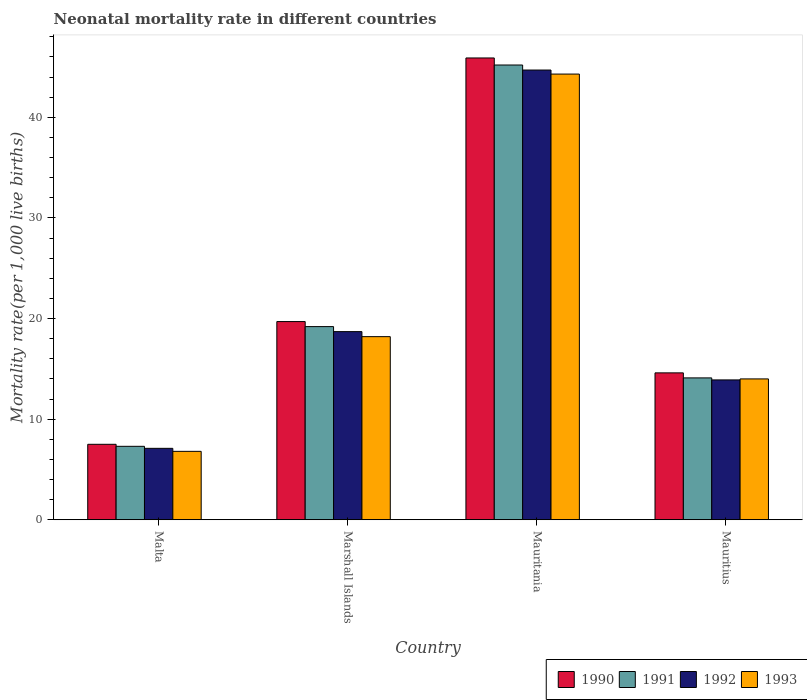Are the number of bars on each tick of the X-axis equal?
Ensure brevity in your answer.  Yes. How many bars are there on the 2nd tick from the left?
Give a very brief answer. 4. How many bars are there on the 4th tick from the right?
Provide a succinct answer. 4. What is the label of the 3rd group of bars from the left?
Keep it short and to the point. Mauritania. In how many cases, is the number of bars for a given country not equal to the number of legend labels?
Give a very brief answer. 0. What is the neonatal mortality rate in 1993 in Mauritius?
Ensure brevity in your answer.  14. Across all countries, what is the maximum neonatal mortality rate in 1993?
Your answer should be very brief. 44.3. Across all countries, what is the minimum neonatal mortality rate in 1990?
Offer a very short reply. 7.5. In which country was the neonatal mortality rate in 1990 maximum?
Ensure brevity in your answer.  Mauritania. In which country was the neonatal mortality rate in 1990 minimum?
Make the answer very short. Malta. What is the total neonatal mortality rate in 1990 in the graph?
Your answer should be very brief. 87.7. What is the difference between the neonatal mortality rate in 1991 in Marshall Islands and that in Mauritania?
Your answer should be very brief. -26. What is the difference between the neonatal mortality rate in 1990 in Marshall Islands and the neonatal mortality rate in 1991 in Mauritius?
Your answer should be very brief. 5.6. What is the average neonatal mortality rate in 1990 per country?
Your response must be concise. 21.92. What is the ratio of the neonatal mortality rate in 1991 in Marshall Islands to that in Mauritius?
Offer a very short reply. 1.36. Is the neonatal mortality rate in 1992 in Marshall Islands less than that in Mauritania?
Make the answer very short. Yes. What is the difference between the highest and the second highest neonatal mortality rate in 1991?
Provide a succinct answer. -26. What is the difference between the highest and the lowest neonatal mortality rate in 1990?
Your response must be concise. 38.4. Is it the case that in every country, the sum of the neonatal mortality rate in 1991 and neonatal mortality rate in 1992 is greater than the sum of neonatal mortality rate in 1990 and neonatal mortality rate in 1993?
Your answer should be very brief. No. What does the 4th bar from the left in Malta represents?
Keep it short and to the point. 1993. Does the graph contain any zero values?
Your response must be concise. No. Where does the legend appear in the graph?
Provide a short and direct response. Bottom right. How are the legend labels stacked?
Make the answer very short. Horizontal. What is the title of the graph?
Offer a terse response. Neonatal mortality rate in different countries. Does "1986" appear as one of the legend labels in the graph?
Provide a succinct answer. No. What is the label or title of the Y-axis?
Make the answer very short. Mortality rate(per 1,0 live births). What is the Mortality rate(per 1,000 live births) of 1990 in Malta?
Your answer should be very brief. 7.5. What is the Mortality rate(per 1,000 live births) in 1991 in Malta?
Your answer should be very brief. 7.3. What is the Mortality rate(per 1,000 live births) in 1993 in Malta?
Offer a very short reply. 6.8. What is the Mortality rate(per 1,000 live births) of 1992 in Marshall Islands?
Ensure brevity in your answer.  18.7. What is the Mortality rate(per 1,000 live births) of 1993 in Marshall Islands?
Keep it short and to the point. 18.2. What is the Mortality rate(per 1,000 live births) in 1990 in Mauritania?
Provide a succinct answer. 45.9. What is the Mortality rate(per 1,000 live births) of 1991 in Mauritania?
Ensure brevity in your answer.  45.2. What is the Mortality rate(per 1,000 live births) of 1992 in Mauritania?
Your response must be concise. 44.7. What is the Mortality rate(per 1,000 live births) in 1993 in Mauritania?
Make the answer very short. 44.3. What is the Mortality rate(per 1,000 live births) in 1991 in Mauritius?
Provide a short and direct response. 14.1. What is the Mortality rate(per 1,000 live births) of 1993 in Mauritius?
Give a very brief answer. 14. Across all countries, what is the maximum Mortality rate(per 1,000 live births) of 1990?
Keep it short and to the point. 45.9. Across all countries, what is the maximum Mortality rate(per 1,000 live births) of 1991?
Provide a succinct answer. 45.2. Across all countries, what is the maximum Mortality rate(per 1,000 live births) in 1992?
Provide a short and direct response. 44.7. Across all countries, what is the maximum Mortality rate(per 1,000 live births) of 1993?
Provide a succinct answer. 44.3. Across all countries, what is the minimum Mortality rate(per 1,000 live births) of 1990?
Provide a short and direct response. 7.5. Across all countries, what is the minimum Mortality rate(per 1,000 live births) in 1992?
Ensure brevity in your answer.  7.1. What is the total Mortality rate(per 1,000 live births) in 1990 in the graph?
Your response must be concise. 87.7. What is the total Mortality rate(per 1,000 live births) in 1991 in the graph?
Your response must be concise. 85.8. What is the total Mortality rate(per 1,000 live births) of 1992 in the graph?
Provide a succinct answer. 84.4. What is the total Mortality rate(per 1,000 live births) of 1993 in the graph?
Offer a terse response. 83.3. What is the difference between the Mortality rate(per 1,000 live births) in 1990 in Malta and that in Marshall Islands?
Ensure brevity in your answer.  -12.2. What is the difference between the Mortality rate(per 1,000 live births) in 1991 in Malta and that in Marshall Islands?
Offer a very short reply. -11.9. What is the difference between the Mortality rate(per 1,000 live births) of 1992 in Malta and that in Marshall Islands?
Give a very brief answer. -11.6. What is the difference between the Mortality rate(per 1,000 live births) in 1990 in Malta and that in Mauritania?
Ensure brevity in your answer.  -38.4. What is the difference between the Mortality rate(per 1,000 live births) of 1991 in Malta and that in Mauritania?
Ensure brevity in your answer.  -37.9. What is the difference between the Mortality rate(per 1,000 live births) in 1992 in Malta and that in Mauritania?
Ensure brevity in your answer.  -37.6. What is the difference between the Mortality rate(per 1,000 live births) in 1993 in Malta and that in Mauritania?
Your answer should be very brief. -37.5. What is the difference between the Mortality rate(per 1,000 live births) in 1991 in Malta and that in Mauritius?
Provide a short and direct response. -6.8. What is the difference between the Mortality rate(per 1,000 live births) in 1990 in Marshall Islands and that in Mauritania?
Make the answer very short. -26.2. What is the difference between the Mortality rate(per 1,000 live births) in 1991 in Marshall Islands and that in Mauritania?
Your answer should be compact. -26. What is the difference between the Mortality rate(per 1,000 live births) in 1993 in Marshall Islands and that in Mauritania?
Offer a terse response. -26.1. What is the difference between the Mortality rate(per 1,000 live births) in 1990 in Mauritania and that in Mauritius?
Make the answer very short. 31.3. What is the difference between the Mortality rate(per 1,000 live births) in 1991 in Mauritania and that in Mauritius?
Keep it short and to the point. 31.1. What is the difference between the Mortality rate(per 1,000 live births) in 1992 in Mauritania and that in Mauritius?
Keep it short and to the point. 30.8. What is the difference between the Mortality rate(per 1,000 live births) of 1993 in Mauritania and that in Mauritius?
Ensure brevity in your answer.  30.3. What is the difference between the Mortality rate(per 1,000 live births) in 1990 in Malta and the Mortality rate(per 1,000 live births) in 1991 in Marshall Islands?
Give a very brief answer. -11.7. What is the difference between the Mortality rate(per 1,000 live births) in 1990 in Malta and the Mortality rate(per 1,000 live births) in 1992 in Marshall Islands?
Make the answer very short. -11.2. What is the difference between the Mortality rate(per 1,000 live births) in 1992 in Malta and the Mortality rate(per 1,000 live births) in 1993 in Marshall Islands?
Keep it short and to the point. -11.1. What is the difference between the Mortality rate(per 1,000 live births) in 1990 in Malta and the Mortality rate(per 1,000 live births) in 1991 in Mauritania?
Keep it short and to the point. -37.7. What is the difference between the Mortality rate(per 1,000 live births) in 1990 in Malta and the Mortality rate(per 1,000 live births) in 1992 in Mauritania?
Your response must be concise. -37.2. What is the difference between the Mortality rate(per 1,000 live births) of 1990 in Malta and the Mortality rate(per 1,000 live births) of 1993 in Mauritania?
Your response must be concise. -36.8. What is the difference between the Mortality rate(per 1,000 live births) in 1991 in Malta and the Mortality rate(per 1,000 live births) in 1992 in Mauritania?
Your answer should be very brief. -37.4. What is the difference between the Mortality rate(per 1,000 live births) of 1991 in Malta and the Mortality rate(per 1,000 live births) of 1993 in Mauritania?
Keep it short and to the point. -37. What is the difference between the Mortality rate(per 1,000 live births) in 1992 in Malta and the Mortality rate(per 1,000 live births) in 1993 in Mauritania?
Provide a short and direct response. -37.2. What is the difference between the Mortality rate(per 1,000 live births) in 1990 in Malta and the Mortality rate(per 1,000 live births) in 1992 in Mauritius?
Provide a succinct answer. -6.4. What is the difference between the Mortality rate(per 1,000 live births) of 1990 in Malta and the Mortality rate(per 1,000 live births) of 1993 in Mauritius?
Offer a terse response. -6.5. What is the difference between the Mortality rate(per 1,000 live births) of 1991 in Malta and the Mortality rate(per 1,000 live births) of 1993 in Mauritius?
Your answer should be compact. -6.7. What is the difference between the Mortality rate(per 1,000 live births) of 1992 in Malta and the Mortality rate(per 1,000 live births) of 1993 in Mauritius?
Your answer should be very brief. -6.9. What is the difference between the Mortality rate(per 1,000 live births) of 1990 in Marshall Islands and the Mortality rate(per 1,000 live births) of 1991 in Mauritania?
Keep it short and to the point. -25.5. What is the difference between the Mortality rate(per 1,000 live births) in 1990 in Marshall Islands and the Mortality rate(per 1,000 live births) in 1992 in Mauritania?
Keep it short and to the point. -25. What is the difference between the Mortality rate(per 1,000 live births) of 1990 in Marshall Islands and the Mortality rate(per 1,000 live births) of 1993 in Mauritania?
Your answer should be compact. -24.6. What is the difference between the Mortality rate(per 1,000 live births) of 1991 in Marshall Islands and the Mortality rate(per 1,000 live births) of 1992 in Mauritania?
Your answer should be very brief. -25.5. What is the difference between the Mortality rate(per 1,000 live births) in 1991 in Marshall Islands and the Mortality rate(per 1,000 live births) in 1993 in Mauritania?
Keep it short and to the point. -25.1. What is the difference between the Mortality rate(per 1,000 live births) of 1992 in Marshall Islands and the Mortality rate(per 1,000 live births) of 1993 in Mauritania?
Provide a succinct answer. -25.6. What is the difference between the Mortality rate(per 1,000 live births) of 1991 in Marshall Islands and the Mortality rate(per 1,000 live births) of 1992 in Mauritius?
Make the answer very short. 5.3. What is the difference between the Mortality rate(per 1,000 live births) of 1991 in Marshall Islands and the Mortality rate(per 1,000 live births) of 1993 in Mauritius?
Give a very brief answer. 5.2. What is the difference between the Mortality rate(per 1,000 live births) of 1992 in Marshall Islands and the Mortality rate(per 1,000 live births) of 1993 in Mauritius?
Provide a succinct answer. 4.7. What is the difference between the Mortality rate(per 1,000 live births) of 1990 in Mauritania and the Mortality rate(per 1,000 live births) of 1991 in Mauritius?
Your answer should be very brief. 31.8. What is the difference between the Mortality rate(per 1,000 live births) of 1990 in Mauritania and the Mortality rate(per 1,000 live births) of 1992 in Mauritius?
Your answer should be very brief. 32. What is the difference between the Mortality rate(per 1,000 live births) in 1990 in Mauritania and the Mortality rate(per 1,000 live births) in 1993 in Mauritius?
Keep it short and to the point. 31.9. What is the difference between the Mortality rate(per 1,000 live births) in 1991 in Mauritania and the Mortality rate(per 1,000 live births) in 1992 in Mauritius?
Ensure brevity in your answer.  31.3. What is the difference between the Mortality rate(per 1,000 live births) of 1991 in Mauritania and the Mortality rate(per 1,000 live births) of 1993 in Mauritius?
Make the answer very short. 31.2. What is the difference between the Mortality rate(per 1,000 live births) in 1992 in Mauritania and the Mortality rate(per 1,000 live births) in 1993 in Mauritius?
Ensure brevity in your answer.  30.7. What is the average Mortality rate(per 1,000 live births) in 1990 per country?
Make the answer very short. 21.93. What is the average Mortality rate(per 1,000 live births) of 1991 per country?
Offer a terse response. 21.45. What is the average Mortality rate(per 1,000 live births) of 1992 per country?
Your response must be concise. 21.1. What is the average Mortality rate(per 1,000 live births) of 1993 per country?
Keep it short and to the point. 20.82. What is the difference between the Mortality rate(per 1,000 live births) of 1991 and Mortality rate(per 1,000 live births) of 1992 in Malta?
Your response must be concise. 0.2. What is the difference between the Mortality rate(per 1,000 live births) of 1991 and Mortality rate(per 1,000 live births) of 1993 in Malta?
Give a very brief answer. 0.5. What is the difference between the Mortality rate(per 1,000 live births) in 1992 and Mortality rate(per 1,000 live births) in 1993 in Malta?
Keep it short and to the point. 0.3. What is the difference between the Mortality rate(per 1,000 live births) of 1992 and Mortality rate(per 1,000 live births) of 1993 in Marshall Islands?
Keep it short and to the point. 0.5. What is the difference between the Mortality rate(per 1,000 live births) in 1991 and Mortality rate(per 1,000 live births) in 1993 in Mauritania?
Offer a very short reply. 0.9. What is the difference between the Mortality rate(per 1,000 live births) in 1992 and Mortality rate(per 1,000 live births) in 1993 in Mauritania?
Your answer should be very brief. 0.4. What is the difference between the Mortality rate(per 1,000 live births) in 1990 and Mortality rate(per 1,000 live births) in 1992 in Mauritius?
Keep it short and to the point. 0.7. What is the difference between the Mortality rate(per 1,000 live births) of 1991 and Mortality rate(per 1,000 live births) of 1992 in Mauritius?
Offer a very short reply. 0.2. What is the difference between the Mortality rate(per 1,000 live births) in 1992 and Mortality rate(per 1,000 live births) in 1993 in Mauritius?
Make the answer very short. -0.1. What is the ratio of the Mortality rate(per 1,000 live births) in 1990 in Malta to that in Marshall Islands?
Make the answer very short. 0.38. What is the ratio of the Mortality rate(per 1,000 live births) of 1991 in Malta to that in Marshall Islands?
Make the answer very short. 0.38. What is the ratio of the Mortality rate(per 1,000 live births) of 1992 in Malta to that in Marshall Islands?
Provide a short and direct response. 0.38. What is the ratio of the Mortality rate(per 1,000 live births) of 1993 in Malta to that in Marshall Islands?
Offer a very short reply. 0.37. What is the ratio of the Mortality rate(per 1,000 live births) of 1990 in Malta to that in Mauritania?
Give a very brief answer. 0.16. What is the ratio of the Mortality rate(per 1,000 live births) of 1991 in Malta to that in Mauritania?
Your answer should be very brief. 0.16. What is the ratio of the Mortality rate(per 1,000 live births) in 1992 in Malta to that in Mauritania?
Your answer should be compact. 0.16. What is the ratio of the Mortality rate(per 1,000 live births) of 1993 in Malta to that in Mauritania?
Ensure brevity in your answer.  0.15. What is the ratio of the Mortality rate(per 1,000 live births) in 1990 in Malta to that in Mauritius?
Your answer should be compact. 0.51. What is the ratio of the Mortality rate(per 1,000 live births) in 1991 in Malta to that in Mauritius?
Ensure brevity in your answer.  0.52. What is the ratio of the Mortality rate(per 1,000 live births) in 1992 in Malta to that in Mauritius?
Ensure brevity in your answer.  0.51. What is the ratio of the Mortality rate(per 1,000 live births) of 1993 in Malta to that in Mauritius?
Provide a short and direct response. 0.49. What is the ratio of the Mortality rate(per 1,000 live births) in 1990 in Marshall Islands to that in Mauritania?
Provide a short and direct response. 0.43. What is the ratio of the Mortality rate(per 1,000 live births) in 1991 in Marshall Islands to that in Mauritania?
Your response must be concise. 0.42. What is the ratio of the Mortality rate(per 1,000 live births) in 1992 in Marshall Islands to that in Mauritania?
Offer a terse response. 0.42. What is the ratio of the Mortality rate(per 1,000 live births) in 1993 in Marshall Islands to that in Mauritania?
Keep it short and to the point. 0.41. What is the ratio of the Mortality rate(per 1,000 live births) in 1990 in Marshall Islands to that in Mauritius?
Offer a very short reply. 1.35. What is the ratio of the Mortality rate(per 1,000 live births) in 1991 in Marshall Islands to that in Mauritius?
Provide a succinct answer. 1.36. What is the ratio of the Mortality rate(per 1,000 live births) in 1992 in Marshall Islands to that in Mauritius?
Provide a short and direct response. 1.35. What is the ratio of the Mortality rate(per 1,000 live births) in 1993 in Marshall Islands to that in Mauritius?
Ensure brevity in your answer.  1.3. What is the ratio of the Mortality rate(per 1,000 live births) of 1990 in Mauritania to that in Mauritius?
Your answer should be very brief. 3.14. What is the ratio of the Mortality rate(per 1,000 live births) of 1991 in Mauritania to that in Mauritius?
Provide a short and direct response. 3.21. What is the ratio of the Mortality rate(per 1,000 live births) of 1992 in Mauritania to that in Mauritius?
Offer a very short reply. 3.22. What is the ratio of the Mortality rate(per 1,000 live births) of 1993 in Mauritania to that in Mauritius?
Provide a succinct answer. 3.16. What is the difference between the highest and the second highest Mortality rate(per 1,000 live births) in 1990?
Ensure brevity in your answer.  26.2. What is the difference between the highest and the second highest Mortality rate(per 1,000 live births) in 1991?
Your answer should be compact. 26. What is the difference between the highest and the second highest Mortality rate(per 1,000 live births) in 1992?
Make the answer very short. 26. What is the difference between the highest and the second highest Mortality rate(per 1,000 live births) in 1993?
Provide a succinct answer. 26.1. What is the difference between the highest and the lowest Mortality rate(per 1,000 live births) of 1990?
Keep it short and to the point. 38.4. What is the difference between the highest and the lowest Mortality rate(per 1,000 live births) in 1991?
Keep it short and to the point. 37.9. What is the difference between the highest and the lowest Mortality rate(per 1,000 live births) of 1992?
Make the answer very short. 37.6. What is the difference between the highest and the lowest Mortality rate(per 1,000 live births) in 1993?
Ensure brevity in your answer.  37.5. 